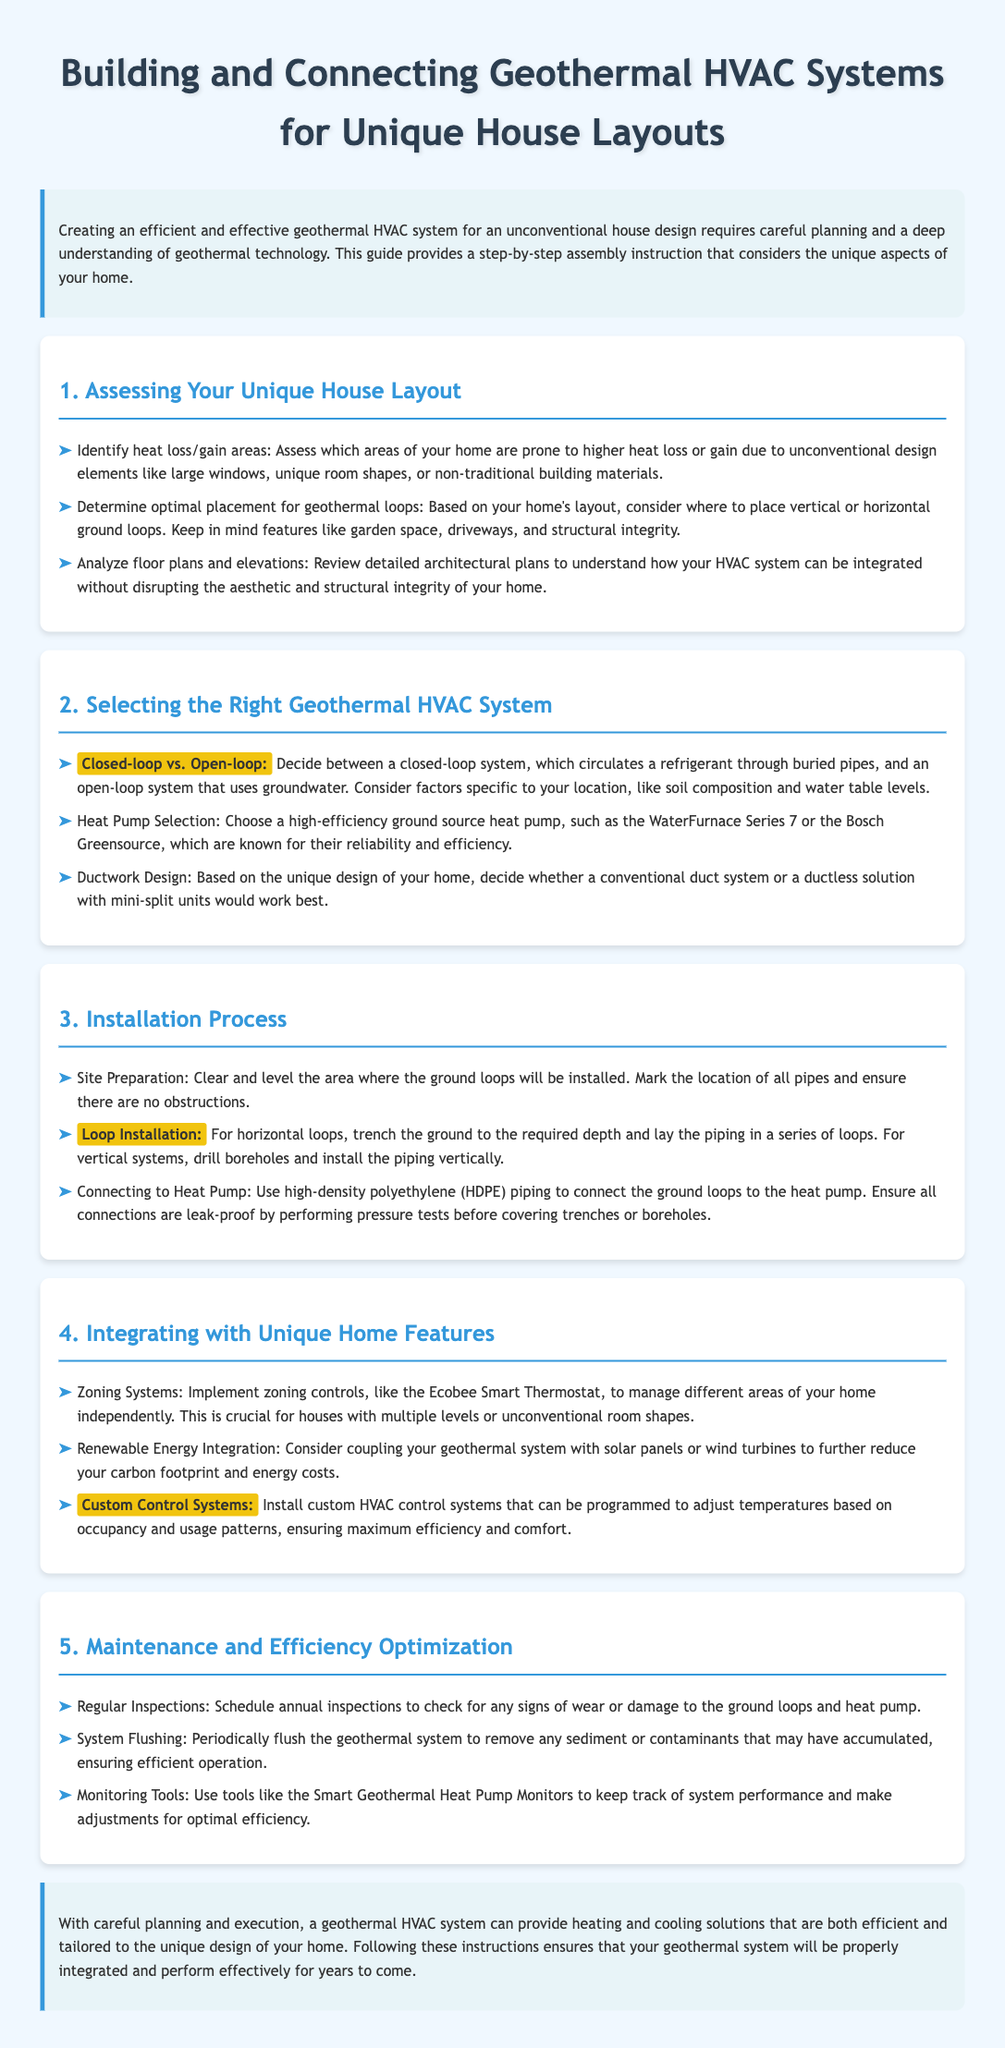What is the first step in assessing your unique house layout? The first step in assessing your unique house layout involves identifying heat loss/gain areas.
Answer: Identifying heat loss/gain areas What are the two types of geothermal systems mentioned? The document mentions closed-loop and open-loop systems as the two types of geothermal systems.
Answer: Closed-loop and open-loop Which heat pump models are suggested? The document suggests the WaterFurnace Series 7 and the Bosch Greensource as reliable heat pump models.
Answer: WaterFurnace Series 7 or Bosch Greensource What type of piping is used to connect the ground loops to the heat pump? The piping used to connect the ground loops to the heat pump is high-density polyethylene (HDPE) piping.
Answer: High-density polyethylene (HDPE) What is one feature mentioned for managing different areas of your home? The document mentions implementing zoning systems like the Ecobee Smart Thermostat as a feature for managing different areas of your home.
Answer: Zoning systems What should be scheduled annually for the geothermal system? The document states that regular inspections should be scheduled annually to check for wear or damage.
Answer: Annual inspections What should be done periodically to ensure efficient operation? The document suggests that the geothermal system should be periodically flushed to remove sediment or contaminants.
Answer: Periodically flushed What is the primary focus of the conclusion? The primary focus of the conclusion is the proper integration and effective performance of the geothermal system for years to come.
Answer: Proper integration and effective performance What type of control system allows adjustments based on occupancy? Custom control systems allow adjustments based on occupancy and usage patterns.
Answer: Custom control systems 